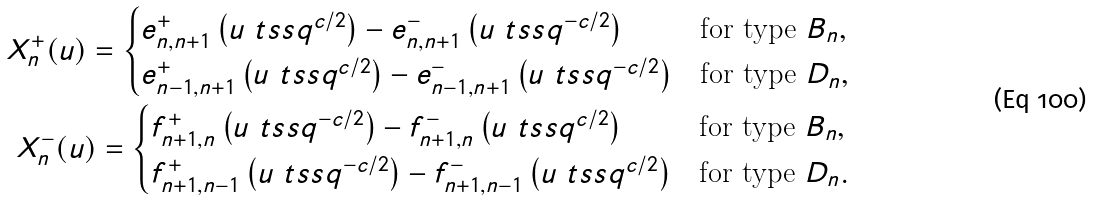Convert formula to latex. <formula><loc_0><loc_0><loc_500><loc_500>X ^ { + } _ { n } ( u ) = \begin{cases} e ^ { + } _ { n , n + 1 } \left ( u \ t s s q ^ { c / 2 } \right ) - e _ { n , n + 1 } ^ { - } \left ( u \ t s s q ^ { - c / 2 } \right ) & \text {for type $B_{n}$} , \\ e ^ { + } _ { n - 1 , n + 1 } \left ( u \ t s s q ^ { c / 2 } \right ) - e _ { n - 1 , n + 1 } ^ { - } \left ( u \ t s s q ^ { - c / 2 } \right ) & \text {for type $D_{n}$} , \end{cases} \\ X ^ { - } _ { n } ( u ) = \begin{cases} f ^ { + } _ { n + 1 , n } \left ( u \ t s s q ^ { - c / 2 } \right ) - f ^ { - } _ { n + 1 , n } \left ( u \ t s s q ^ { c / 2 } \right ) & \text {for type $B_{n}$} , \\ f ^ { + } _ { n + 1 , n - 1 } \left ( u \ t s s q ^ { - c / 2 } \right ) - f ^ { - } _ { n + 1 , n - 1 } \left ( u \ t s s q ^ { c / 2 } \right ) & \text {for type $D_{n}$} . \end{cases}</formula> 